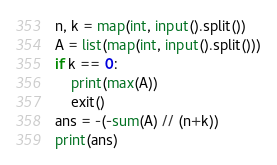<code> <loc_0><loc_0><loc_500><loc_500><_Python_>n, k = map(int, input().split())
A = list(map(int, input().split()))
if k == 0:
    print(max(A))
    exit()
ans = -(-sum(A) // (n+k))
print(ans)</code> 